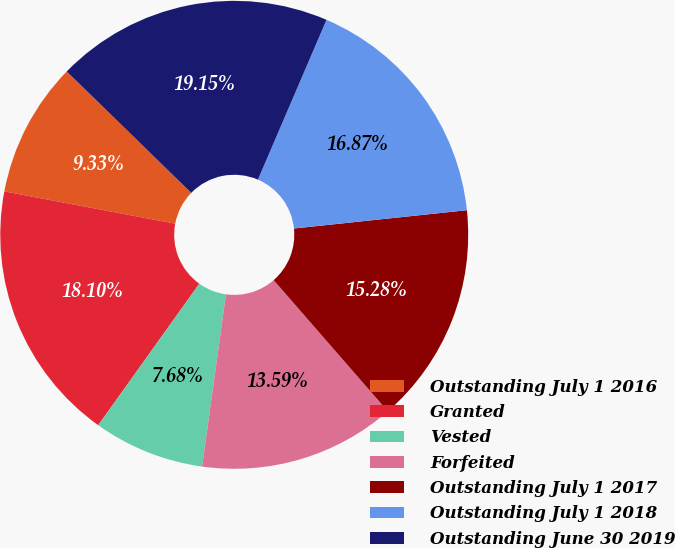Convert chart. <chart><loc_0><loc_0><loc_500><loc_500><pie_chart><fcel>Outstanding July 1 2016<fcel>Granted<fcel>Vested<fcel>Forfeited<fcel>Outstanding July 1 2017<fcel>Outstanding July 1 2018<fcel>Outstanding June 30 2019<nl><fcel>9.33%<fcel>18.1%<fcel>7.68%<fcel>13.59%<fcel>15.28%<fcel>16.87%<fcel>19.15%<nl></chart> 